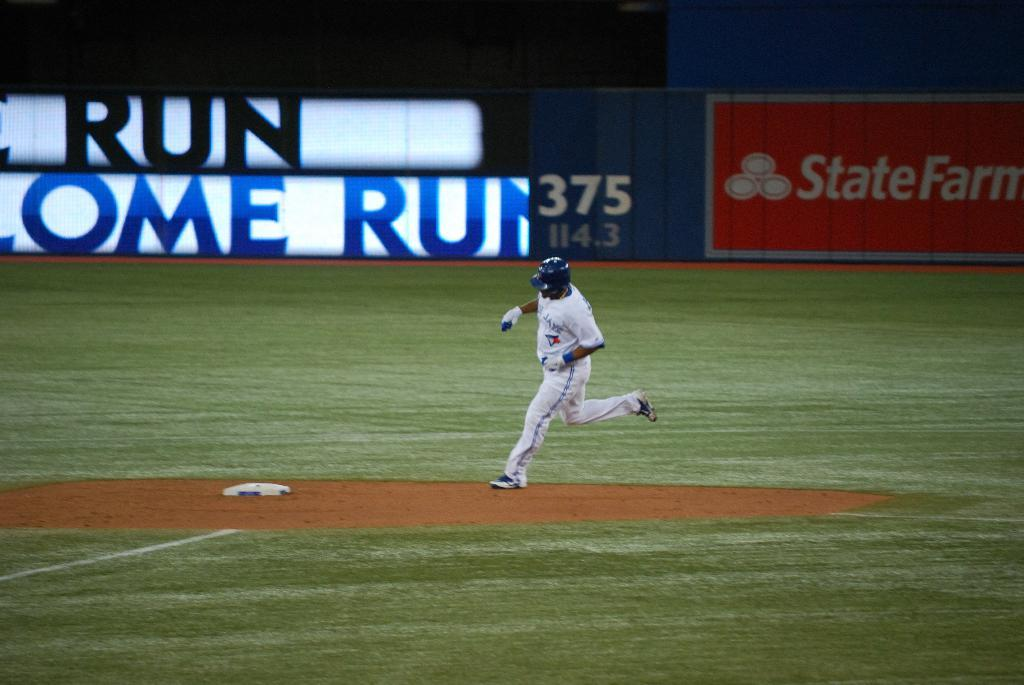<image>
Render a clear and concise summary of the photo. a player rounding the base with 375 in the outfield 